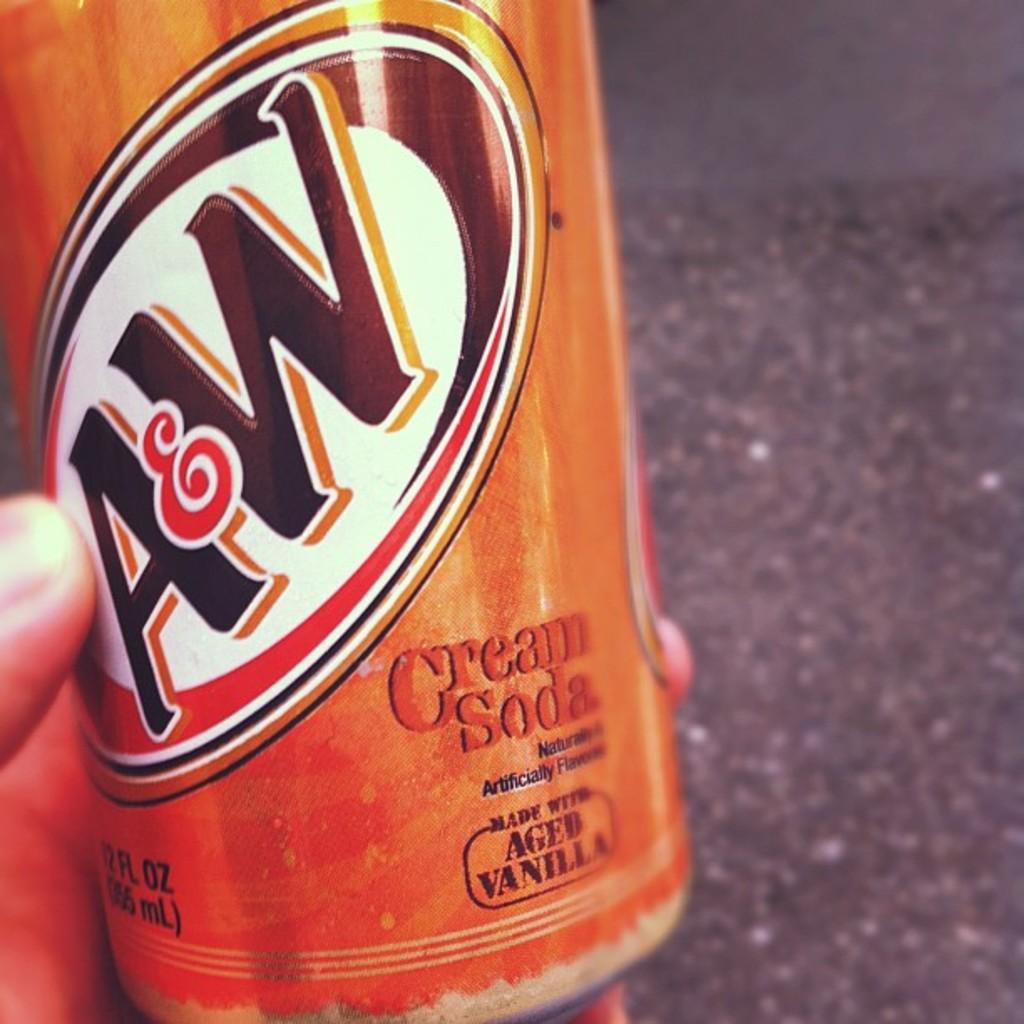<image>
Provide a brief description of the given image. A brown tin can of A&W branded Cream soda. 